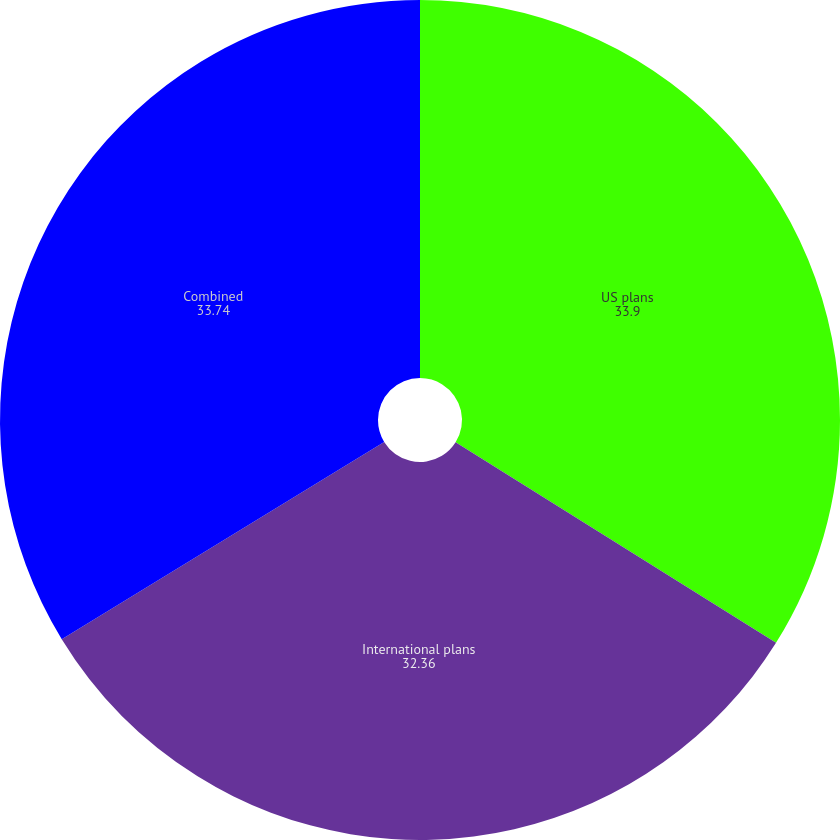Convert chart. <chart><loc_0><loc_0><loc_500><loc_500><pie_chart><fcel>US plans<fcel>International plans<fcel>Combined<nl><fcel>33.9%<fcel>32.36%<fcel>33.74%<nl></chart> 